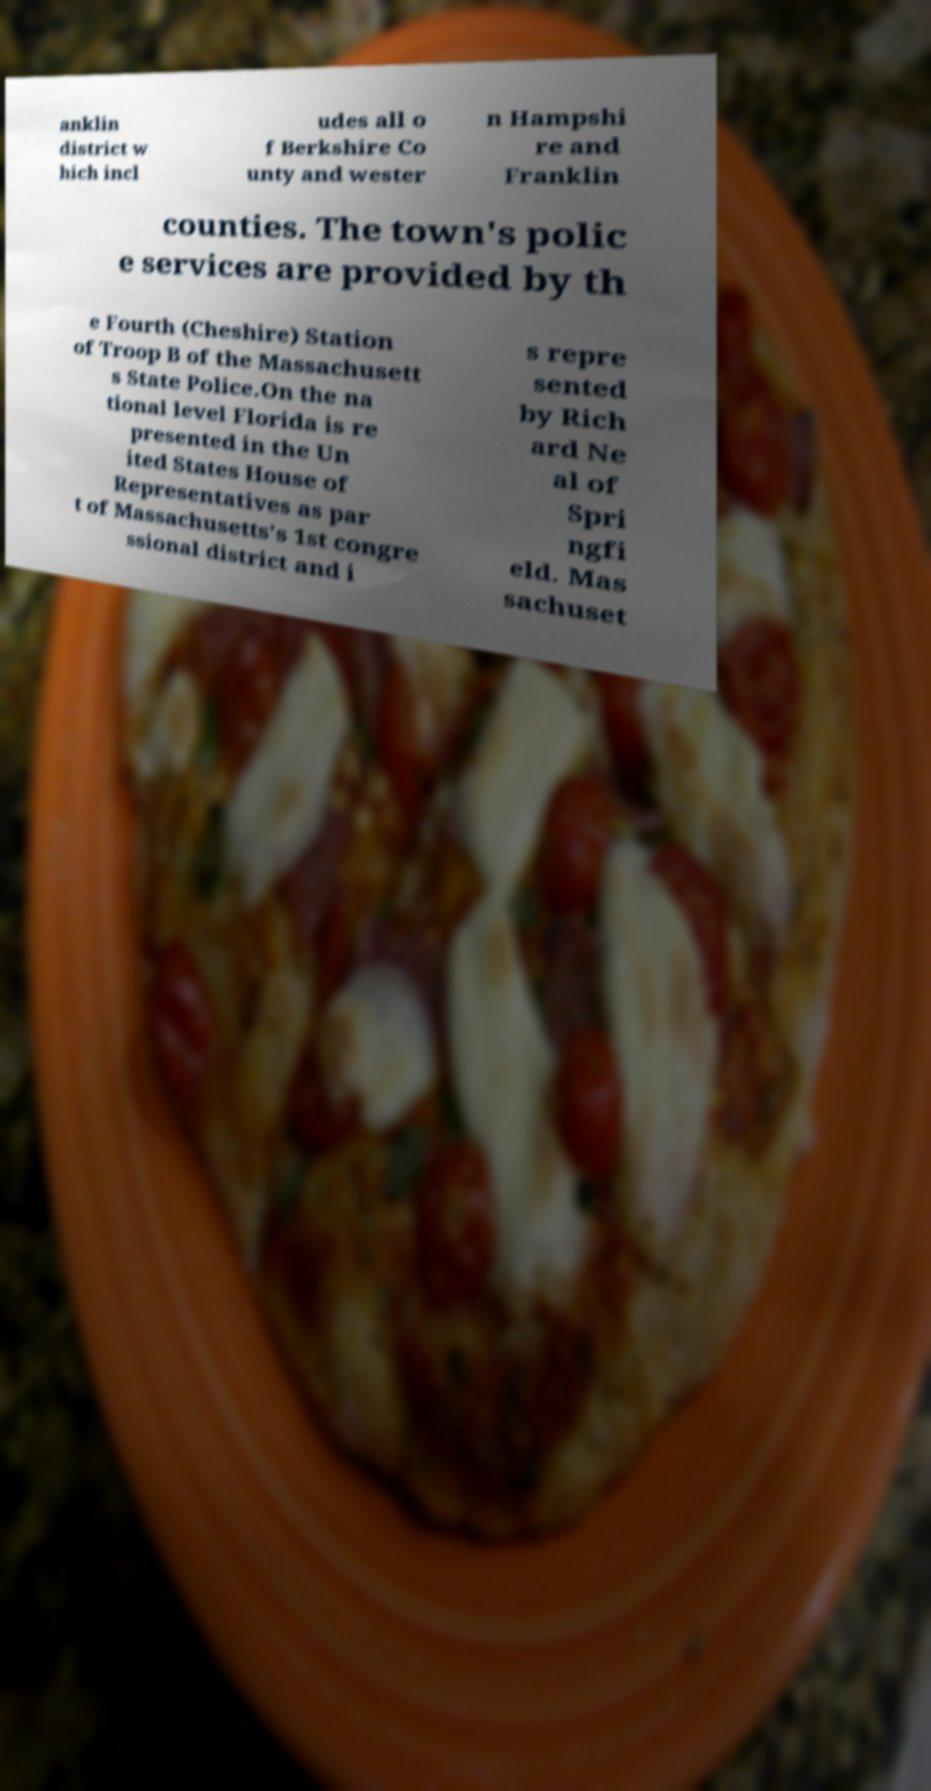There's text embedded in this image that I need extracted. Can you transcribe it verbatim? anklin district w hich incl udes all o f Berkshire Co unty and wester n Hampshi re and Franklin counties. The town's polic e services are provided by th e Fourth (Cheshire) Station of Troop B of the Massachusett s State Police.On the na tional level Florida is re presented in the Un ited States House of Representatives as par t of Massachusetts's 1st congre ssional district and i s repre sented by Rich ard Ne al of Spri ngfi eld. Mas sachuset 